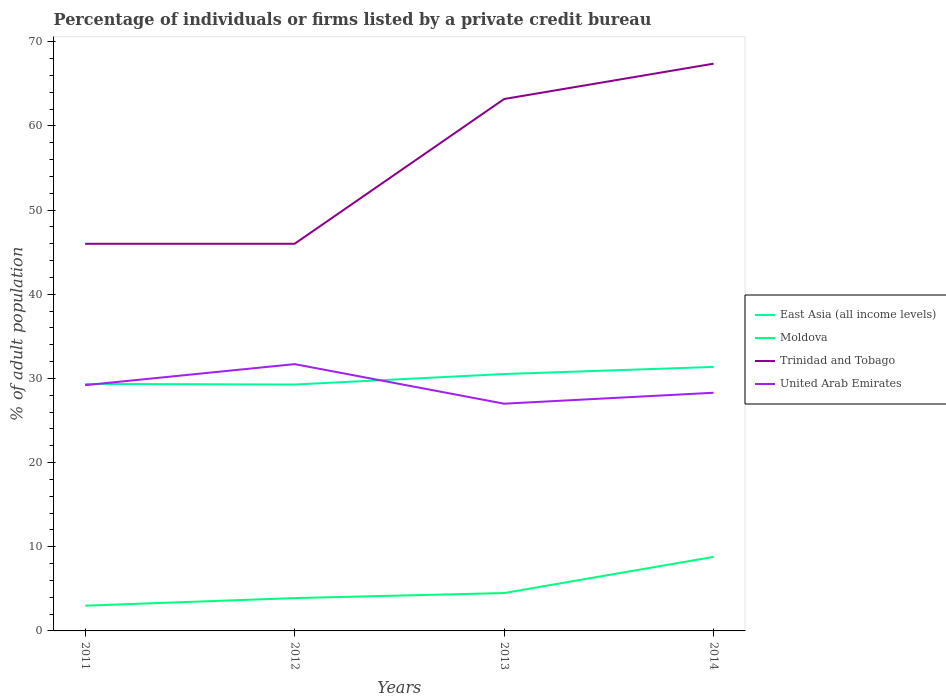How many different coloured lines are there?
Offer a very short reply. 4. Does the line corresponding to East Asia (all income levels) intersect with the line corresponding to Trinidad and Tobago?
Your response must be concise. No. Is the number of lines equal to the number of legend labels?
Your response must be concise. Yes. Across all years, what is the maximum percentage of population listed by a private credit bureau in East Asia (all income levels)?
Provide a short and direct response. 29.28. What is the difference between the highest and the second highest percentage of population listed by a private credit bureau in Trinidad and Tobago?
Offer a terse response. 21.4. Is the percentage of population listed by a private credit bureau in United Arab Emirates strictly greater than the percentage of population listed by a private credit bureau in Trinidad and Tobago over the years?
Provide a short and direct response. Yes. How many lines are there?
Your answer should be compact. 4. How many years are there in the graph?
Ensure brevity in your answer.  4. Are the values on the major ticks of Y-axis written in scientific E-notation?
Keep it short and to the point. No. Does the graph contain grids?
Offer a terse response. No. What is the title of the graph?
Offer a terse response. Percentage of individuals or firms listed by a private credit bureau. What is the label or title of the X-axis?
Give a very brief answer. Years. What is the label or title of the Y-axis?
Make the answer very short. % of adult population. What is the % of adult population of East Asia (all income levels) in 2011?
Your answer should be compact. 29.35. What is the % of adult population of Trinidad and Tobago in 2011?
Ensure brevity in your answer.  46. What is the % of adult population of United Arab Emirates in 2011?
Offer a terse response. 29.2. What is the % of adult population of East Asia (all income levels) in 2012?
Give a very brief answer. 29.28. What is the % of adult population of United Arab Emirates in 2012?
Your response must be concise. 31.7. What is the % of adult population in East Asia (all income levels) in 2013?
Provide a succinct answer. 30.52. What is the % of adult population of Trinidad and Tobago in 2013?
Your answer should be very brief. 63.2. What is the % of adult population of United Arab Emirates in 2013?
Make the answer very short. 27. What is the % of adult population of East Asia (all income levels) in 2014?
Make the answer very short. 31.37. What is the % of adult population in Moldova in 2014?
Ensure brevity in your answer.  8.8. What is the % of adult population in Trinidad and Tobago in 2014?
Provide a short and direct response. 67.4. What is the % of adult population in United Arab Emirates in 2014?
Your response must be concise. 28.3. Across all years, what is the maximum % of adult population of East Asia (all income levels)?
Offer a terse response. 31.37. Across all years, what is the maximum % of adult population in Trinidad and Tobago?
Your response must be concise. 67.4. Across all years, what is the maximum % of adult population in United Arab Emirates?
Offer a very short reply. 31.7. Across all years, what is the minimum % of adult population of East Asia (all income levels)?
Your answer should be very brief. 29.28. What is the total % of adult population in East Asia (all income levels) in the graph?
Your answer should be very brief. 120.52. What is the total % of adult population of Moldova in the graph?
Offer a terse response. 20.2. What is the total % of adult population in Trinidad and Tobago in the graph?
Offer a terse response. 222.6. What is the total % of adult population of United Arab Emirates in the graph?
Keep it short and to the point. 116.2. What is the difference between the % of adult population of East Asia (all income levels) in 2011 and that in 2012?
Your response must be concise. 0.07. What is the difference between the % of adult population of Moldova in 2011 and that in 2012?
Give a very brief answer. -0.9. What is the difference between the % of adult population in United Arab Emirates in 2011 and that in 2012?
Your answer should be compact. -2.5. What is the difference between the % of adult population in East Asia (all income levels) in 2011 and that in 2013?
Make the answer very short. -1.18. What is the difference between the % of adult population in Trinidad and Tobago in 2011 and that in 2013?
Keep it short and to the point. -17.2. What is the difference between the % of adult population of East Asia (all income levels) in 2011 and that in 2014?
Your answer should be compact. -2.02. What is the difference between the % of adult population of Trinidad and Tobago in 2011 and that in 2014?
Offer a terse response. -21.4. What is the difference between the % of adult population in United Arab Emirates in 2011 and that in 2014?
Ensure brevity in your answer.  0.9. What is the difference between the % of adult population in East Asia (all income levels) in 2012 and that in 2013?
Offer a terse response. -1.25. What is the difference between the % of adult population in Trinidad and Tobago in 2012 and that in 2013?
Make the answer very short. -17.2. What is the difference between the % of adult population of East Asia (all income levels) in 2012 and that in 2014?
Keep it short and to the point. -2.09. What is the difference between the % of adult population of Trinidad and Tobago in 2012 and that in 2014?
Make the answer very short. -21.4. What is the difference between the % of adult population in United Arab Emirates in 2012 and that in 2014?
Your answer should be very brief. 3.4. What is the difference between the % of adult population in East Asia (all income levels) in 2013 and that in 2014?
Your answer should be very brief. -0.84. What is the difference between the % of adult population in Trinidad and Tobago in 2013 and that in 2014?
Provide a short and direct response. -4.2. What is the difference between the % of adult population of East Asia (all income levels) in 2011 and the % of adult population of Moldova in 2012?
Make the answer very short. 25.45. What is the difference between the % of adult population in East Asia (all income levels) in 2011 and the % of adult population in Trinidad and Tobago in 2012?
Provide a short and direct response. -16.65. What is the difference between the % of adult population of East Asia (all income levels) in 2011 and the % of adult population of United Arab Emirates in 2012?
Your answer should be compact. -2.35. What is the difference between the % of adult population in Moldova in 2011 and the % of adult population in Trinidad and Tobago in 2012?
Your answer should be very brief. -43. What is the difference between the % of adult population of Moldova in 2011 and the % of adult population of United Arab Emirates in 2012?
Ensure brevity in your answer.  -28.7. What is the difference between the % of adult population of East Asia (all income levels) in 2011 and the % of adult population of Moldova in 2013?
Ensure brevity in your answer.  24.85. What is the difference between the % of adult population in East Asia (all income levels) in 2011 and the % of adult population in Trinidad and Tobago in 2013?
Make the answer very short. -33.85. What is the difference between the % of adult population in East Asia (all income levels) in 2011 and the % of adult population in United Arab Emirates in 2013?
Keep it short and to the point. 2.35. What is the difference between the % of adult population of Moldova in 2011 and the % of adult population of Trinidad and Tobago in 2013?
Provide a succinct answer. -60.2. What is the difference between the % of adult population of Moldova in 2011 and the % of adult population of United Arab Emirates in 2013?
Offer a very short reply. -24. What is the difference between the % of adult population of Trinidad and Tobago in 2011 and the % of adult population of United Arab Emirates in 2013?
Ensure brevity in your answer.  19. What is the difference between the % of adult population of East Asia (all income levels) in 2011 and the % of adult population of Moldova in 2014?
Provide a short and direct response. 20.55. What is the difference between the % of adult population of East Asia (all income levels) in 2011 and the % of adult population of Trinidad and Tobago in 2014?
Give a very brief answer. -38.05. What is the difference between the % of adult population in East Asia (all income levels) in 2011 and the % of adult population in United Arab Emirates in 2014?
Provide a succinct answer. 1.05. What is the difference between the % of adult population of Moldova in 2011 and the % of adult population of Trinidad and Tobago in 2014?
Make the answer very short. -64.4. What is the difference between the % of adult population of Moldova in 2011 and the % of adult population of United Arab Emirates in 2014?
Make the answer very short. -25.3. What is the difference between the % of adult population of East Asia (all income levels) in 2012 and the % of adult population of Moldova in 2013?
Make the answer very short. 24.78. What is the difference between the % of adult population of East Asia (all income levels) in 2012 and the % of adult population of Trinidad and Tobago in 2013?
Make the answer very short. -33.92. What is the difference between the % of adult population of East Asia (all income levels) in 2012 and the % of adult population of United Arab Emirates in 2013?
Make the answer very short. 2.28. What is the difference between the % of adult population of Moldova in 2012 and the % of adult population of Trinidad and Tobago in 2013?
Offer a very short reply. -59.3. What is the difference between the % of adult population of Moldova in 2012 and the % of adult population of United Arab Emirates in 2013?
Make the answer very short. -23.1. What is the difference between the % of adult population in East Asia (all income levels) in 2012 and the % of adult population in Moldova in 2014?
Your answer should be very brief. 20.48. What is the difference between the % of adult population of East Asia (all income levels) in 2012 and the % of adult population of Trinidad and Tobago in 2014?
Provide a short and direct response. -38.12. What is the difference between the % of adult population in East Asia (all income levels) in 2012 and the % of adult population in United Arab Emirates in 2014?
Offer a very short reply. 0.98. What is the difference between the % of adult population in Moldova in 2012 and the % of adult population in Trinidad and Tobago in 2014?
Your answer should be compact. -63.5. What is the difference between the % of adult population of Moldova in 2012 and the % of adult population of United Arab Emirates in 2014?
Offer a terse response. -24.4. What is the difference between the % of adult population in Trinidad and Tobago in 2012 and the % of adult population in United Arab Emirates in 2014?
Your answer should be compact. 17.7. What is the difference between the % of adult population of East Asia (all income levels) in 2013 and the % of adult population of Moldova in 2014?
Your answer should be compact. 21.72. What is the difference between the % of adult population in East Asia (all income levels) in 2013 and the % of adult population in Trinidad and Tobago in 2014?
Your response must be concise. -36.88. What is the difference between the % of adult population of East Asia (all income levels) in 2013 and the % of adult population of United Arab Emirates in 2014?
Your response must be concise. 2.22. What is the difference between the % of adult population of Moldova in 2013 and the % of adult population of Trinidad and Tobago in 2014?
Give a very brief answer. -62.9. What is the difference between the % of adult population in Moldova in 2013 and the % of adult population in United Arab Emirates in 2014?
Ensure brevity in your answer.  -23.8. What is the difference between the % of adult population in Trinidad and Tobago in 2013 and the % of adult population in United Arab Emirates in 2014?
Your answer should be very brief. 34.9. What is the average % of adult population in East Asia (all income levels) per year?
Your answer should be compact. 30.13. What is the average % of adult population of Moldova per year?
Give a very brief answer. 5.05. What is the average % of adult population in Trinidad and Tobago per year?
Offer a very short reply. 55.65. What is the average % of adult population in United Arab Emirates per year?
Keep it short and to the point. 29.05. In the year 2011, what is the difference between the % of adult population in East Asia (all income levels) and % of adult population in Moldova?
Make the answer very short. 26.35. In the year 2011, what is the difference between the % of adult population in East Asia (all income levels) and % of adult population in Trinidad and Tobago?
Make the answer very short. -16.65. In the year 2011, what is the difference between the % of adult population of East Asia (all income levels) and % of adult population of United Arab Emirates?
Ensure brevity in your answer.  0.15. In the year 2011, what is the difference between the % of adult population of Moldova and % of adult population of Trinidad and Tobago?
Offer a very short reply. -43. In the year 2011, what is the difference between the % of adult population in Moldova and % of adult population in United Arab Emirates?
Your answer should be very brief. -26.2. In the year 2012, what is the difference between the % of adult population in East Asia (all income levels) and % of adult population in Moldova?
Give a very brief answer. 25.38. In the year 2012, what is the difference between the % of adult population of East Asia (all income levels) and % of adult population of Trinidad and Tobago?
Make the answer very short. -16.72. In the year 2012, what is the difference between the % of adult population of East Asia (all income levels) and % of adult population of United Arab Emirates?
Your answer should be very brief. -2.42. In the year 2012, what is the difference between the % of adult population of Moldova and % of adult population of Trinidad and Tobago?
Keep it short and to the point. -42.1. In the year 2012, what is the difference between the % of adult population in Moldova and % of adult population in United Arab Emirates?
Make the answer very short. -27.8. In the year 2012, what is the difference between the % of adult population of Trinidad and Tobago and % of adult population of United Arab Emirates?
Offer a terse response. 14.3. In the year 2013, what is the difference between the % of adult population of East Asia (all income levels) and % of adult population of Moldova?
Ensure brevity in your answer.  26.02. In the year 2013, what is the difference between the % of adult population in East Asia (all income levels) and % of adult population in Trinidad and Tobago?
Make the answer very short. -32.68. In the year 2013, what is the difference between the % of adult population of East Asia (all income levels) and % of adult population of United Arab Emirates?
Provide a succinct answer. 3.52. In the year 2013, what is the difference between the % of adult population of Moldova and % of adult population of Trinidad and Tobago?
Give a very brief answer. -58.7. In the year 2013, what is the difference between the % of adult population of Moldova and % of adult population of United Arab Emirates?
Offer a terse response. -22.5. In the year 2013, what is the difference between the % of adult population in Trinidad and Tobago and % of adult population in United Arab Emirates?
Your answer should be very brief. 36.2. In the year 2014, what is the difference between the % of adult population of East Asia (all income levels) and % of adult population of Moldova?
Your answer should be very brief. 22.57. In the year 2014, what is the difference between the % of adult population of East Asia (all income levels) and % of adult population of Trinidad and Tobago?
Offer a very short reply. -36.03. In the year 2014, what is the difference between the % of adult population of East Asia (all income levels) and % of adult population of United Arab Emirates?
Offer a terse response. 3.07. In the year 2014, what is the difference between the % of adult population of Moldova and % of adult population of Trinidad and Tobago?
Give a very brief answer. -58.6. In the year 2014, what is the difference between the % of adult population of Moldova and % of adult population of United Arab Emirates?
Provide a succinct answer. -19.5. In the year 2014, what is the difference between the % of adult population of Trinidad and Tobago and % of adult population of United Arab Emirates?
Keep it short and to the point. 39.1. What is the ratio of the % of adult population in East Asia (all income levels) in 2011 to that in 2012?
Offer a terse response. 1. What is the ratio of the % of adult population of Moldova in 2011 to that in 2012?
Your answer should be compact. 0.77. What is the ratio of the % of adult population of Trinidad and Tobago in 2011 to that in 2012?
Offer a very short reply. 1. What is the ratio of the % of adult population of United Arab Emirates in 2011 to that in 2012?
Provide a short and direct response. 0.92. What is the ratio of the % of adult population in East Asia (all income levels) in 2011 to that in 2013?
Make the answer very short. 0.96. What is the ratio of the % of adult population of Trinidad and Tobago in 2011 to that in 2013?
Give a very brief answer. 0.73. What is the ratio of the % of adult population in United Arab Emirates in 2011 to that in 2013?
Ensure brevity in your answer.  1.08. What is the ratio of the % of adult population in East Asia (all income levels) in 2011 to that in 2014?
Give a very brief answer. 0.94. What is the ratio of the % of adult population in Moldova in 2011 to that in 2014?
Your answer should be compact. 0.34. What is the ratio of the % of adult population of Trinidad and Tobago in 2011 to that in 2014?
Your answer should be very brief. 0.68. What is the ratio of the % of adult population in United Arab Emirates in 2011 to that in 2014?
Your answer should be very brief. 1.03. What is the ratio of the % of adult population in East Asia (all income levels) in 2012 to that in 2013?
Give a very brief answer. 0.96. What is the ratio of the % of adult population of Moldova in 2012 to that in 2013?
Offer a terse response. 0.87. What is the ratio of the % of adult population of Trinidad and Tobago in 2012 to that in 2013?
Give a very brief answer. 0.73. What is the ratio of the % of adult population in United Arab Emirates in 2012 to that in 2013?
Provide a succinct answer. 1.17. What is the ratio of the % of adult population in Moldova in 2012 to that in 2014?
Your response must be concise. 0.44. What is the ratio of the % of adult population in Trinidad and Tobago in 2012 to that in 2014?
Provide a short and direct response. 0.68. What is the ratio of the % of adult population in United Arab Emirates in 2012 to that in 2014?
Offer a very short reply. 1.12. What is the ratio of the % of adult population of East Asia (all income levels) in 2013 to that in 2014?
Your response must be concise. 0.97. What is the ratio of the % of adult population of Moldova in 2013 to that in 2014?
Provide a short and direct response. 0.51. What is the ratio of the % of adult population of Trinidad and Tobago in 2013 to that in 2014?
Ensure brevity in your answer.  0.94. What is the ratio of the % of adult population of United Arab Emirates in 2013 to that in 2014?
Offer a very short reply. 0.95. What is the difference between the highest and the second highest % of adult population of East Asia (all income levels)?
Your answer should be very brief. 0.84. What is the difference between the highest and the second highest % of adult population in Moldova?
Make the answer very short. 4.3. What is the difference between the highest and the second highest % of adult population of Trinidad and Tobago?
Your answer should be compact. 4.2. What is the difference between the highest and the second highest % of adult population of United Arab Emirates?
Offer a terse response. 2.5. What is the difference between the highest and the lowest % of adult population of East Asia (all income levels)?
Your answer should be very brief. 2.09. What is the difference between the highest and the lowest % of adult population in Moldova?
Your response must be concise. 5.8. What is the difference between the highest and the lowest % of adult population in Trinidad and Tobago?
Offer a very short reply. 21.4. 